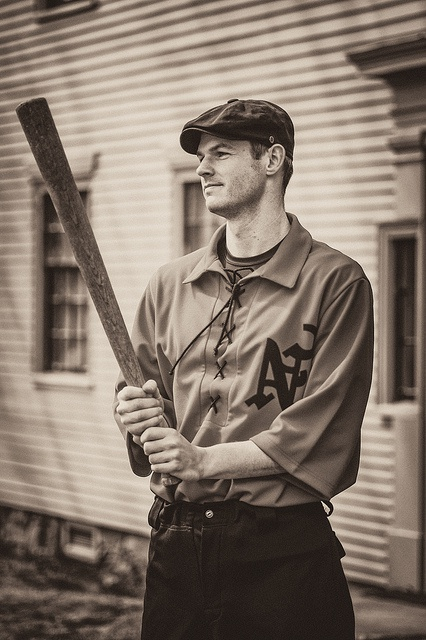Describe the objects in this image and their specific colors. I can see people in gray, black, darkgray, and tan tones and baseball bat in gray and black tones in this image. 